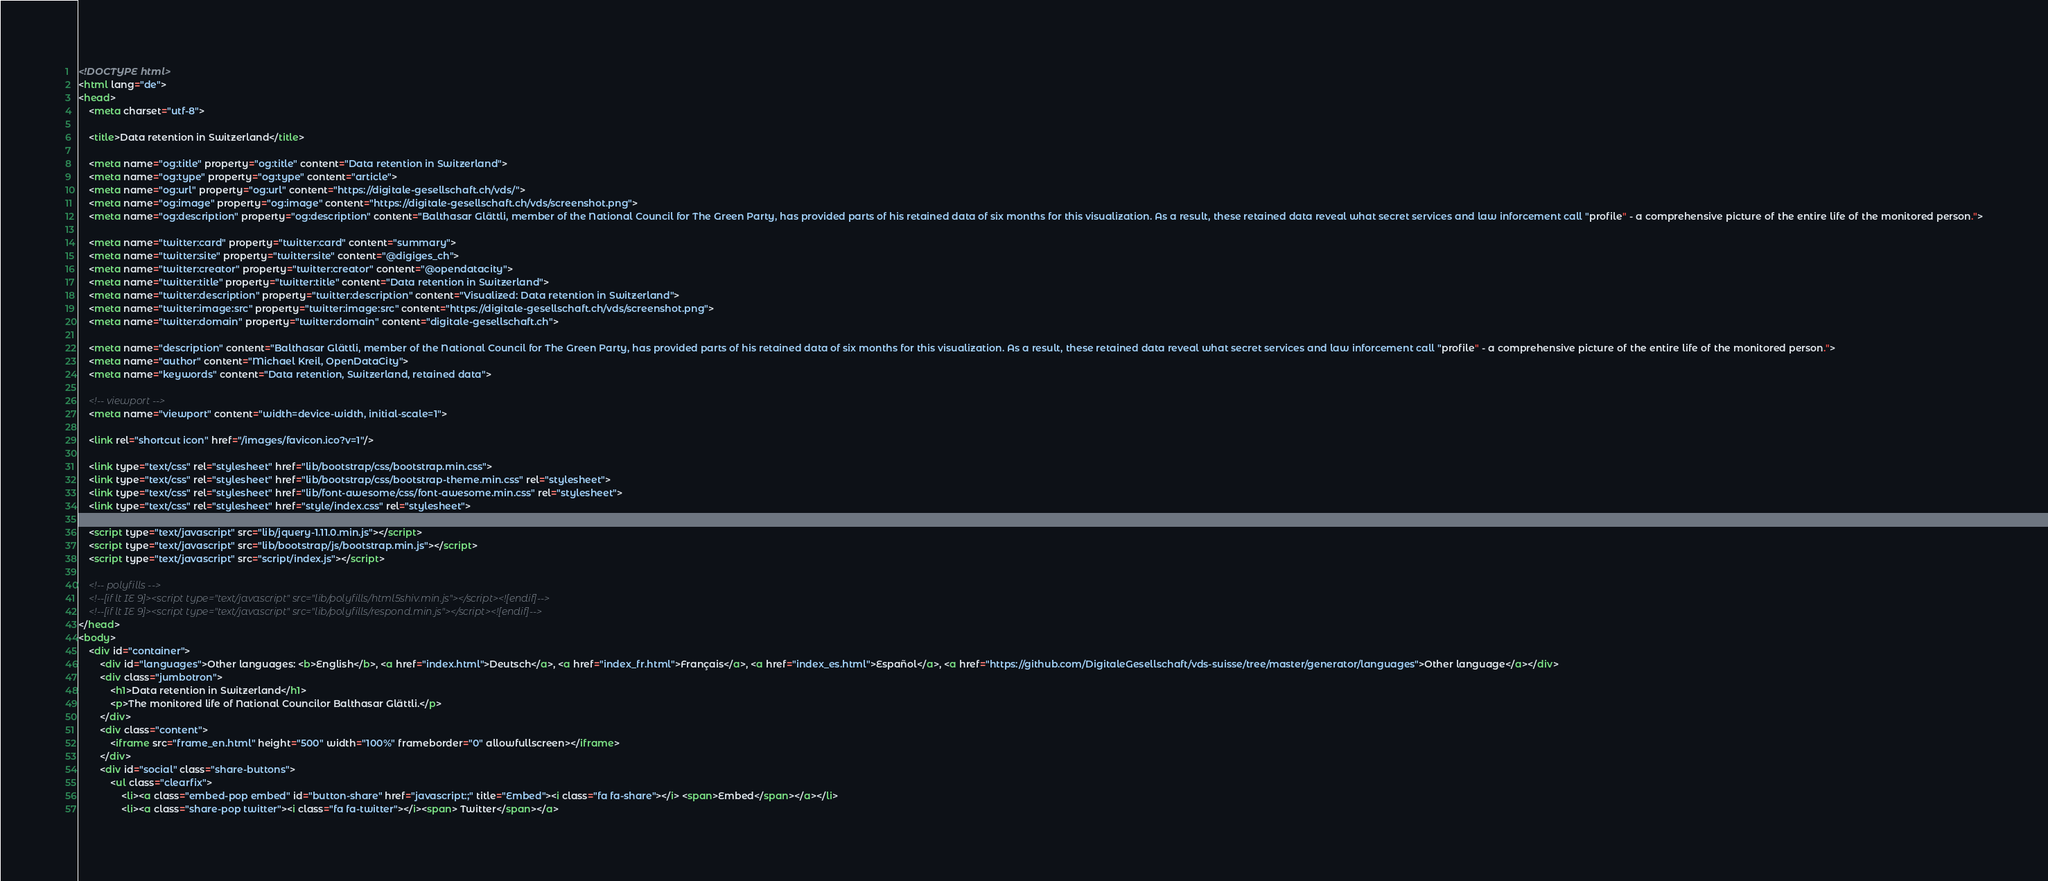<code> <loc_0><loc_0><loc_500><loc_500><_HTML_><!DOCTYPE html>
<html lang="de">
<head>
	<meta charset="utf-8">

	<title>Data retention in Switzerland</title>

	<meta name="og:title" property="og:title" content="Data retention in Switzerland">
	<meta name="og:type" property="og:type" content="article">
	<meta name="og:url" property="og:url" content="https://digitale-gesellschaft.ch/vds/">
	<meta name="og:image" property="og:image" content="https://digitale-gesellschaft.ch/vds/screenshot.png">
	<meta name="og:description" property="og:description" content="Balthasar Glättli, member of the National Council for The Green Party, has provided parts of his retained data of six months for this visualization. As a result, these retained data reveal what secret services and law inforcement call "profile" - a comprehensive picture of the entire life of the monitored person.">

	<meta name="twitter:card" property="twitter:card" content="summary">
	<meta name="twitter:site" property="twitter:site" content="@digiges_ch">
	<meta name="twitter:creator" property="twitter:creator" content="@opendatacity">
	<meta name="twitter:title" property="twitter:title" content="Data retention in Switzerland">
	<meta name="twitter:description" property="twitter:description" content="Visualized: Data retention in Switzerland">
	<meta name="twitter:image:src" property="twitter:image:src" content="https://digitale-gesellschaft.ch/vds/screenshot.png">
	<meta name="twitter:domain" property="twitter:domain" content="digitale-gesellschaft.ch">

	<meta name="description" content="Balthasar Glättli, member of the National Council for The Green Party, has provided parts of his retained data of six months for this visualization. As a result, these retained data reveal what secret services and law inforcement call "profile" - a comprehensive picture of the entire life of the monitored person.">
	<meta name="author" content="Michael Kreil, OpenDataCity">
	<meta name="keywords" content="Data retention, Switzerland, retained data">

	<!-- viewport -->
	<meta name="viewport" content="width=device-width, initial-scale=1">

	<link rel="shortcut icon" href="/images/favicon.ico?v=1"/>

	<link type="text/css" rel="stylesheet" href="lib/bootstrap/css/bootstrap.min.css">
	<link type="text/css" rel="stylesheet" href="lib/bootstrap/css/bootstrap-theme.min.css" rel="stylesheet">
	<link type="text/css" rel="stylesheet" href="lib/font-awesome/css/font-awesome.min.css" rel="stylesheet">
	<link type="text/css" rel="stylesheet" href="style/index.css" rel="stylesheet">

	<script type="text/javascript" src="lib/jquery-1.11.0.min.js"></script>
	<script type="text/javascript" src="lib/bootstrap/js/bootstrap.min.js"></script>
	<script type="text/javascript" src="script/index.js"></script>

	<!-- polyfills -->
	<!--[if lt IE 9]><script type="text/javascript" src="lib/polyfills/html5shiv.min.js"></script><![endif]-->
	<!--[if lt IE 9]><script type="text/javascript" src="lib/polyfills/respond.min.js"></script><![endif]-->
</head>
<body>
	<div id="container">
		<div id="languages">Other languages: <b>English</b>, <a href="index.html">Deutsch</a>, <a href="index_fr.html">Français</a>, <a href="index_es.html">Español</a>, <a href="https://github.com/DigitaleGesellschaft/vds-suisse/tree/master/generator/languages">Other language</a></div>
		<div class="jumbotron">
			<h1>Data retention in Switzerland</h1>
			<p>The monitored life of National Councilor Balthasar Glättli.</p>
		</div>
		<div class="content">
			<iframe src="frame_en.html" height="500" width="100%" frameborder="0" allowfullscreen></iframe>
		</div>
		<div id="social" class="share-buttons">
			<ul class="clearfix">
				<li><a class="embed-pop embed" id="button-share" href="javascript:;" title="Embed"><i class="fa fa-share"></i> <span>Embed</span></a></li>
				<li><a class="share-pop twitter"><i class="fa fa-twitter"></i><span> Twitter</span></a></code> 